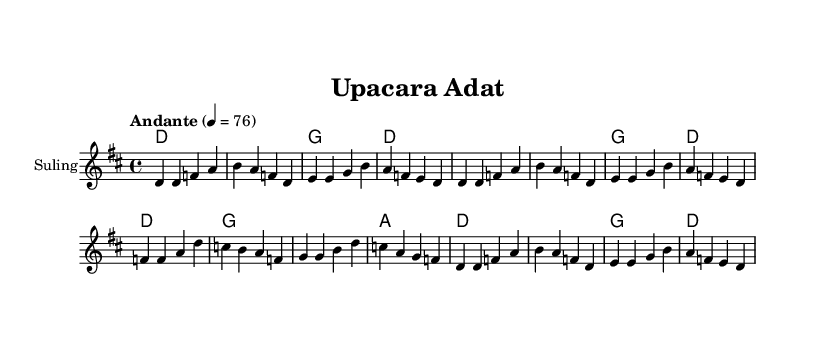What is the key signature of this music? The key signature is indicated at the beginning of the music and shows two sharps, which represent F# and C#. This corresponds to the key of D major.
Answer: D major What is the time signature of this piece? The time signature is shown next to the key signature and is indicated as "4/4." This means there are four beats in a measure and a quarter note receives one beat.
Answer: 4/4 What is the tempo marking of this song? The tempo marking is written above the staff as "Andante" with a metronome marking of 4 = 76, which indicates a moderate walking pace.
Answer: Andante How many measures are in the melody section? By counting all the individual groups of notes (measures) shown in the melody part, there are a total of 12 measures.
Answer: 12 What instrument is used in this piece? The instrument is specified at the beginning of the staff as "Suling," which refers to a traditional Indonesian bamboo flute often used in folk music.
Answer: Suling Which traditional theme is reflected in the song's lyrics? The lyrics mention "Upacara Adat," which translates to "traditional ceremony," reflecting the cultural and ritual themes embedded in Indonesian customs.
Answer: Traditional ceremony What is the last chord in the harmony section? The last chord in the harmony section indicated is "D," which is the final chord in the sequence, completing the harmonic structure of the piece.
Answer: D 